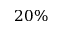Convert formula to latex. <formula><loc_0><loc_0><loc_500><loc_500>2 0 \%</formula> 